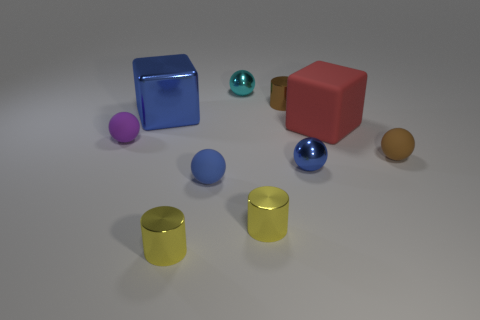Subtract all brown rubber spheres. How many spheres are left? 4 Subtract all cyan spheres. How many spheres are left? 4 Subtract all yellow balls. Subtract all purple cubes. How many balls are left? 5 Subtract all blocks. How many objects are left? 8 Subtract 0 green cylinders. How many objects are left? 10 Subtract all cyan cylinders. Subtract all blue cubes. How many objects are left? 9 Add 1 blue matte objects. How many blue matte objects are left? 2 Add 2 large green metallic objects. How many large green metallic objects exist? 2 